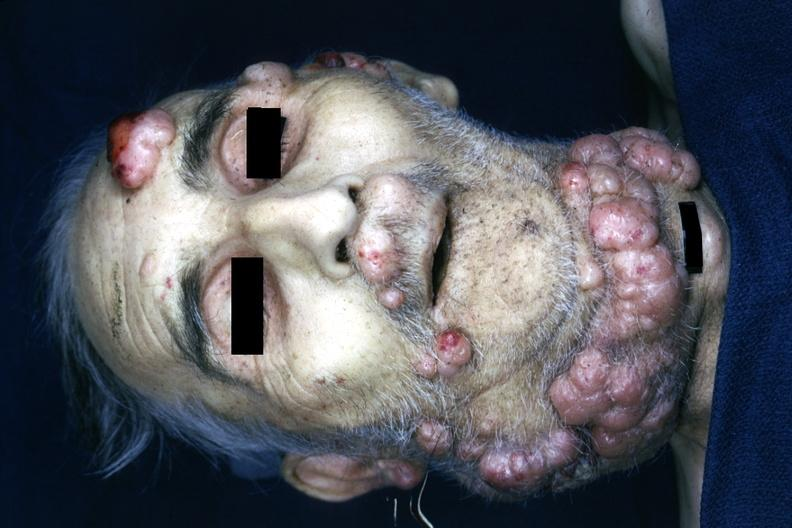does this good yellow color slide recklinghausen disease is present?
Answer the question using a single word or phrase. No 